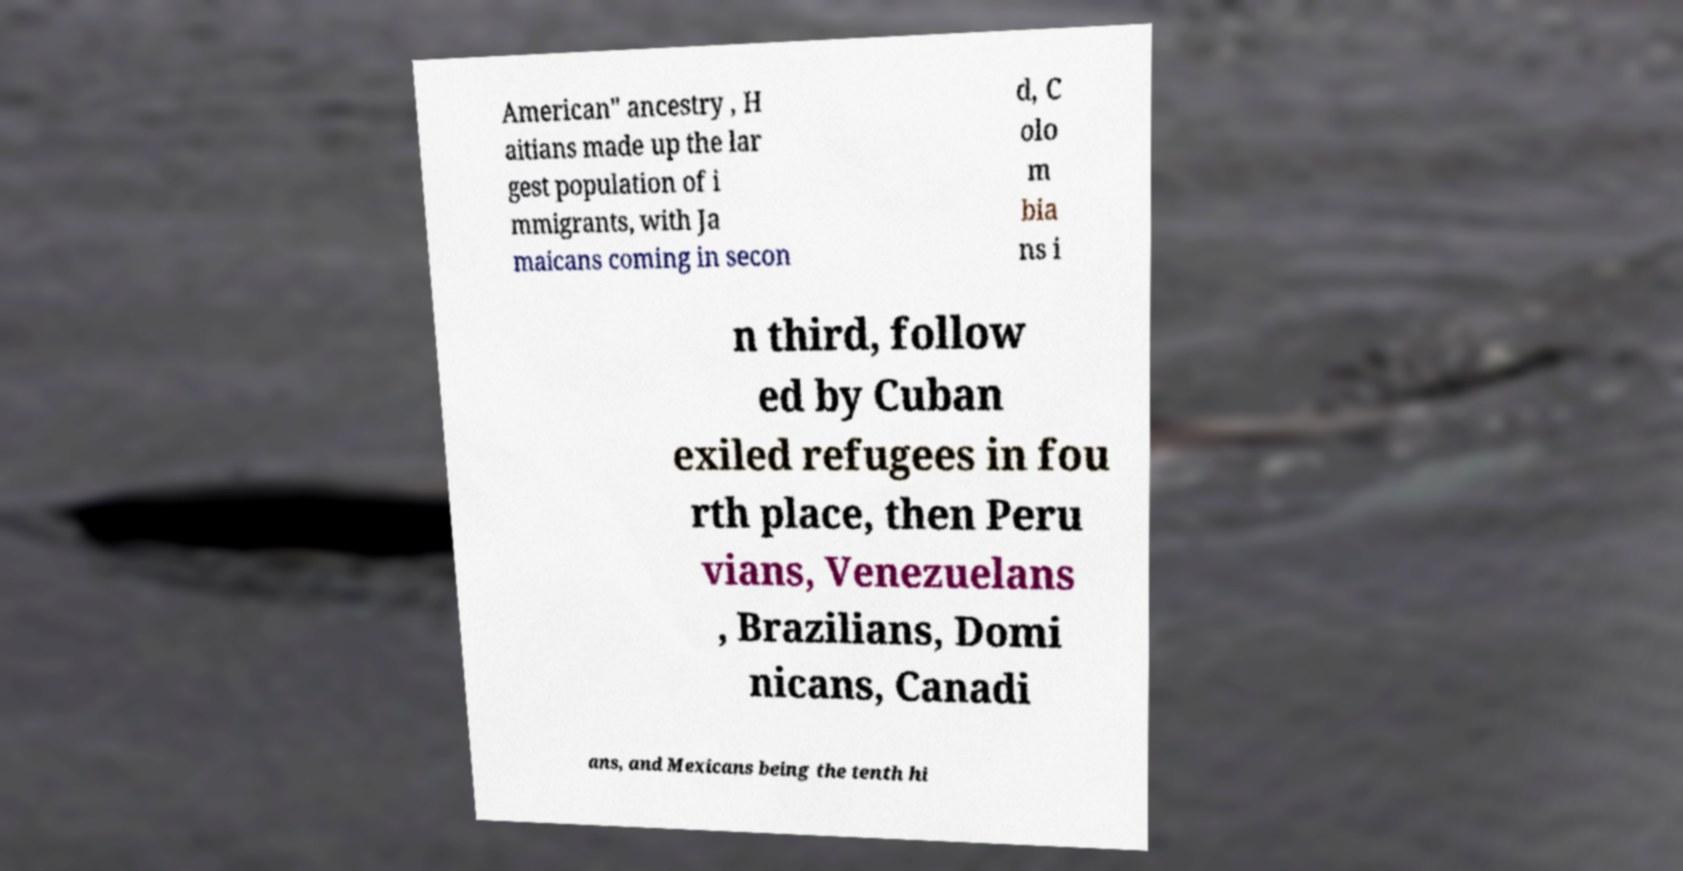Can you read and provide the text displayed in the image?This photo seems to have some interesting text. Can you extract and type it out for me? American" ancestry , H aitians made up the lar gest population of i mmigrants, with Ja maicans coming in secon d, C olo m bia ns i n third, follow ed by Cuban exiled refugees in fou rth place, then Peru vians, Venezuelans , Brazilians, Domi nicans, Canadi ans, and Mexicans being the tenth hi 